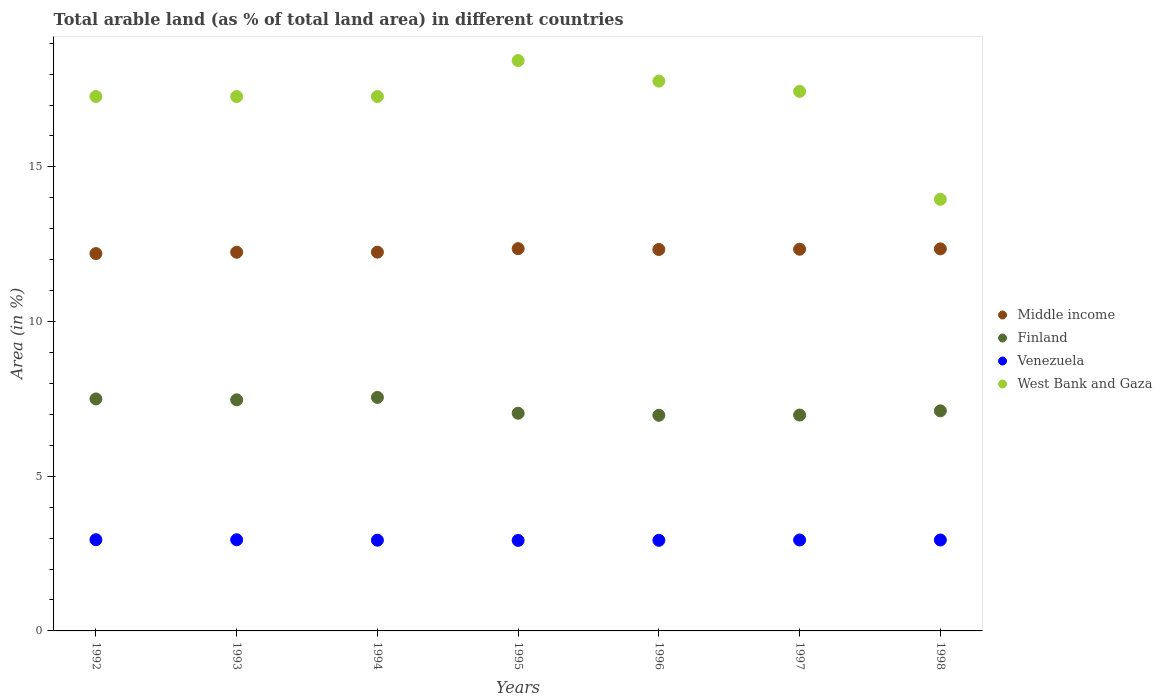How many different coloured dotlines are there?
Your response must be concise. 4. What is the percentage of arable land in Middle income in 1995?
Provide a succinct answer. 12.36. Across all years, what is the maximum percentage of arable land in Finland?
Your response must be concise. 7.55. Across all years, what is the minimum percentage of arable land in Middle income?
Provide a succinct answer. 12.2. What is the total percentage of arable land in West Bank and Gaza in the graph?
Offer a terse response. 119.44. What is the difference between the percentage of arable land in Middle income in 1995 and that in 1997?
Your response must be concise. 0.02. What is the difference between the percentage of arable land in Finland in 1993 and the percentage of arable land in Venezuela in 1994?
Ensure brevity in your answer.  4.54. What is the average percentage of arable land in Venezuela per year?
Your response must be concise. 2.94. In the year 1992, what is the difference between the percentage of arable land in Venezuela and percentage of arable land in Middle income?
Make the answer very short. -9.25. In how many years, is the percentage of arable land in Finland greater than 10 %?
Offer a very short reply. 0. What is the ratio of the percentage of arable land in Finland in 1994 to that in 1996?
Keep it short and to the point. 1.08. Is the difference between the percentage of arable land in Venezuela in 1994 and 1995 greater than the difference between the percentage of arable land in Middle income in 1994 and 1995?
Give a very brief answer. Yes. What is the difference between the highest and the second highest percentage of arable land in Venezuela?
Your response must be concise. 0. What is the difference between the highest and the lowest percentage of arable land in Venezuela?
Keep it short and to the point. 0.02. In how many years, is the percentage of arable land in Finland greater than the average percentage of arable land in Finland taken over all years?
Provide a short and direct response. 3. Is the percentage of arable land in Venezuela strictly greater than the percentage of arable land in West Bank and Gaza over the years?
Provide a short and direct response. No. Is the percentage of arable land in Middle income strictly less than the percentage of arable land in Venezuela over the years?
Offer a very short reply. No. How many dotlines are there?
Make the answer very short. 4. How many years are there in the graph?
Make the answer very short. 7. What is the difference between two consecutive major ticks on the Y-axis?
Make the answer very short. 5. Does the graph contain any zero values?
Give a very brief answer. No. How many legend labels are there?
Your answer should be very brief. 4. How are the legend labels stacked?
Provide a succinct answer. Vertical. What is the title of the graph?
Make the answer very short. Total arable land (as % of total land area) in different countries. What is the label or title of the X-axis?
Offer a terse response. Years. What is the label or title of the Y-axis?
Keep it short and to the point. Area (in %). What is the Area (in %) of Middle income in 1992?
Your answer should be compact. 12.2. What is the Area (in %) of Finland in 1992?
Give a very brief answer. 7.5. What is the Area (in %) in Venezuela in 1992?
Provide a succinct answer. 2.95. What is the Area (in %) of West Bank and Gaza in 1992?
Your answer should be compact. 17.28. What is the Area (in %) in Middle income in 1993?
Provide a succinct answer. 12.24. What is the Area (in %) in Finland in 1993?
Keep it short and to the point. 7.47. What is the Area (in %) of Venezuela in 1993?
Offer a very short reply. 2.95. What is the Area (in %) of West Bank and Gaza in 1993?
Your response must be concise. 17.28. What is the Area (in %) of Middle income in 1994?
Your response must be concise. 12.24. What is the Area (in %) of Finland in 1994?
Offer a very short reply. 7.55. What is the Area (in %) of Venezuela in 1994?
Offer a terse response. 2.93. What is the Area (in %) of West Bank and Gaza in 1994?
Your answer should be compact. 17.28. What is the Area (in %) in Middle income in 1995?
Keep it short and to the point. 12.36. What is the Area (in %) in Finland in 1995?
Provide a short and direct response. 7.04. What is the Area (in %) of Venezuela in 1995?
Offer a terse response. 2.93. What is the Area (in %) of West Bank and Gaza in 1995?
Your answer should be compact. 18.44. What is the Area (in %) of Middle income in 1996?
Give a very brief answer. 12.33. What is the Area (in %) of Finland in 1996?
Make the answer very short. 6.97. What is the Area (in %) in Venezuela in 1996?
Your answer should be very brief. 2.93. What is the Area (in %) in West Bank and Gaza in 1996?
Your response must be concise. 17.77. What is the Area (in %) in Middle income in 1997?
Your answer should be very brief. 12.34. What is the Area (in %) of Finland in 1997?
Provide a short and direct response. 6.98. What is the Area (in %) of Venezuela in 1997?
Provide a succinct answer. 2.94. What is the Area (in %) of West Bank and Gaza in 1997?
Your answer should be compact. 17.44. What is the Area (in %) in Middle income in 1998?
Offer a terse response. 12.35. What is the Area (in %) in Finland in 1998?
Offer a terse response. 7.12. What is the Area (in %) of Venezuela in 1998?
Your answer should be very brief. 2.94. What is the Area (in %) of West Bank and Gaza in 1998?
Ensure brevity in your answer.  13.95. Across all years, what is the maximum Area (in %) in Middle income?
Provide a short and direct response. 12.36. Across all years, what is the maximum Area (in %) in Finland?
Your answer should be compact. 7.55. Across all years, what is the maximum Area (in %) of Venezuela?
Provide a short and direct response. 2.95. Across all years, what is the maximum Area (in %) in West Bank and Gaza?
Offer a terse response. 18.44. Across all years, what is the minimum Area (in %) of Middle income?
Offer a very short reply. 12.2. Across all years, what is the minimum Area (in %) of Finland?
Provide a succinct answer. 6.97. Across all years, what is the minimum Area (in %) in Venezuela?
Your answer should be compact. 2.93. Across all years, what is the minimum Area (in %) of West Bank and Gaza?
Your response must be concise. 13.95. What is the total Area (in %) in Middle income in the graph?
Offer a very short reply. 86.07. What is the total Area (in %) in Finland in the graph?
Provide a short and direct response. 50.62. What is the total Area (in %) of Venezuela in the graph?
Your response must be concise. 20.56. What is the total Area (in %) in West Bank and Gaza in the graph?
Keep it short and to the point. 119.44. What is the difference between the Area (in %) of Middle income in 1992 and that in 1993?
Make the answer very short. -0.04. What is the difference between the Area (in %) in Finland in 1992 and that in 1993?
Keep it short and to the point. 0.03. What is the difference between the Area (in %) of Venezuela in 1992 and that in 1993?
Make the answer very short. 0. What is the difference between the Area (in %) of Middle income in 1992 and that in 1994?
Provide a short and direct response. -0.05. What is the difference between the Area (in %) in Finland in 1992 and that in 1994?
Ensure brevity in your answer.  -0.05. What is the difference between the Area (in %) in Venezuela in 1992 and that in 1994?
Your answer should be very brief. 0.02. What is the difference between the Area (in %) of West Bank and Gaza in 1992 and that in 1994?
Give a very brief answer. 0. What is the difference between the Area (in %) of Middle income in 1992 and that in 1995?
Offer a terse response. -0.16. What is the difference between the Area (in %) in Finland in 1992 and that in 1995?
Your answer should be very brief. 0.46. What is the difference between the Area (in %) in Venezuela in 1992 and that in 1995?
Make the answer very short. 0.02. What is the difference between the Area (in %) of West Bank and Gaza in 1992 and that in 1995?
Ensure brevity in your answer.  -1.16. What is the difference between the Area (in %) in Middle income in 1992 and that in 1996?
Ensure brevity in your answer.  -0.13. What is the difference between the Area (in %) of Finland in 1992 and that in 1996?
Provide a succinct answer. 0.53. What is the difference between the Area (in %) of Venezuela in 1992 and that in 1996?
Offer a very short reply. 0.02. What is the difference between the Area (in %) of West Bank and Gaza in 1992 and that in 1996?
Keep it short and to the point. -0.5. What is the difference between the Area (in %) in Middle income in 1992 and that in 1997?
Your answer should be compact. -0.14. What is the difference between the Area (in %) in Finland in 1992 and that in 1997?
Your answer should be compact. 0.52. What is the difference between the Area (in %) in Venezuela in 1992 and that in 1997?
Provide a short and direct response. 0.01. What is the difference between the Area (in %) of West Bank and Gaza in 1992 and that in 1997?
Make the answer very short. -0.17. What is the difference between the Area (in %) in Middle income in 1992 and that in 1998?
Ensure brevity in your answer.  -0.15. What is the difference between the Area (in %) in Finland in 1992 and that in 1998?
Offer a terse response. 0.38. What is the difference between the Area (in %) of Venezuela in 1992 and that in 1998?
Offer a terse response. 0.01. What is the difference between the Area (in %) of West Bank and Gaza in 1992 and that in 1998?
Offer a terse response. 3.32. What is the difference between the Area (in %) in Middle income in 1993 and that in 1994?
Your response must be concise. -0. What is the difference between the Area (in %) of Finland in 1993 and that in 1994?
Offer a very short reply. -0.08. What is the difference between the Area (in %) of Venezuela in 1993 and that in 1994?
Make the answer very short. 0.01. What is the difference between the Area (in %) in West Bank and Gaza in 1993 and that in 1994?
Make the answer very short. 0. What is the difference between the Area (in %) of Middle income in 1993 and that in 1995?
Your answer should be compact. -0.12. What is the difference between the Area (in %) of Finland in 1993 and that in 1995?
Make the answer very short. 0.43. What is the difference between the Area (in %) of Venezuela in 1993 and that in 1995?
Your response must be concise. 0.02. What is the difference between the Area (in %) in West Bank and Gaza in 1993 and that in 1995?
Ensure brevity in your answer.  -1.16. What is the difference between the Area (in %) in Middle income in 1993 and that in 1996?
Offer a very short reply. -0.09. What is the difference between the Area (in %) of Finland in 1993 and that in 1996?
Your response must be concise. 0.5. What is the difference between the Area (in %) in Venezuela in 1993 and that in 1996?
Make the answer very short. 0.02. What is the difference between the Area (in %) in West Bank and Gaza in 1993 and that in 1996?
Your answer should be compact. -0.5. What is the difference between the Area (in %) of Middle income in 1993 and that in 1997?
Your response must be concise. -0.1. What is the difference between the Area (in %) in Finland in 1993 and that in 1997?
Ensure brevity in your answer.  0.49. What is the difference between the Area (in %) of Venezuela in 1993 and that in 1997?
Provide a succinct answer. 0.01. What is the difference between the Area (in %) in West Bank and Gaza in 1993 and that in 1997?
Offer a terse response. -0.17. What is the difference between the Area (in %) in Middle income in 1993 and that in 1998?
Offer a terse response. -0.11. What is the difference between the Area (in %) of Finland in 1993 and that in 1998?
Provide a succinct answer. 0.36. What is the difference between the Area (in %) in Venezuela in 1993 and that in 1998?
Your response must be concise. 0.01. What is the difference between the Area (in %) of West Bank and Gaza in 1993 and that in 1998?
Give a very brief answer. 3.32. What is the difference between the Area (in %) in Middle income in 1994 and that in 1995?
Provide a short and direct response. -0.11. What is the difference between the Area (in %) of Finland in 1994 and that in 1995?
Keep it short and to the point. 0.51. What is the difference between the Area (in %) in Venezuela in 1994 and that in 1995?
Make the answer very short. 0.01. What is the difference between the Area (in %) in West Bank and Gaza in 1994 and that in 1995?
Your answer should be very brief. -1.16. What is the difference between the Area (in %) in Middle income in 1994 and that in 1996?
Your answer should be compact. -0.09. What is the difference between the Area (in %) of Finland in 1994 and that in 1996?
Your response must be concise. 0.58. What is the difference between the Area (in %) of Venezuela in 1994 and that in 1996?
Keep it short and to the point. 0. What is the difference between the Area (in %) in West Bank and Gaza in 1994 and that in 1996?
Keep it short and to the point. -0.5. What is the difference between the Area (in %) in Middle income in 1994 and that in 1997?
Your response must be concise. -0.09. What is the difference between the Area (in %) of Finland in 1994 and that in 1997?
Give a very brief answer. 0.57. What is the difference between the Area (in %) in Venezuela in 1994 and that in 1997?
Provide a succinct answer. -0.01. What is the difference between the Area (in %) of West Bank and Gaza in 1994 and that in 1997?
Provide a short and direct response. -0.17. What is the difference between the Area (in %) of Middle income in 1994 and that in 1998?
Your response must be concise. -0.11. What is the difference between the Area (in %) in Finland in 1994 and that in 1998?
Offer a very short reply. 0.43. What is the difference between the Area (in %) of Venezuela in 1994 and that in 1998?
Offer a very short reply. -0.01. What is the difference between the Area (in %) in West Bank and Gaza in 1994 and that in 1998?
Your answer should be compact. 3.32. What is the difference between the Area (in %) of Middle income in 1995 and that in 1996?
Provide a succinct answer. 0.03. What is the difference between the Area (in %) of Finland in 1995 and that in 1996?
Your answer should be compact. 0.07. What is the difference between the Area (in %) in Venezuela in 1995 and that in 1996?
Make the answer very short. -0. What is the difference between the Area (in %) of West Bank and Gaza in 1995 and that in 1996?
Offer a very short reply. 0.66. What is the difference between the Area (in %) in Middle income in 1995 and that in 1997?
Offer a terse response. 0.02. What is the difference between the Area (in %) of Finland in 1995 and that in 1997?
Your answer should be very brief. 0.06. What is the difference between the Area (in %) of Venezuela in 1995 and that in 1997?
Your answer should be compact. -0.01. What is the difference between the Area (in %) in West Bank and Gaza in 1995 and that in 1997?
Keep it short and to the point. 1. What is the difference between the Area (in %) in Middle income in 1995 and that in 1998?
Your answer should be compact. 0.01. What is the difference between the Area (in %) in Finland in 1995 and that in 1998?
Provide a succinct answer. -0.08. What is the difference between the Area (in %) in Venezuela in 1995 and that in 1998?
Provide a short and direct response. -0.01. What is the difference between the Area (in %) in West Bank and Gaza in 1995 and that in 1998?
Your answer should be compact. 4.49. What is the difference between the Area (in %) of Middle income in 1996 and that in 1997?
Offer a terse response. -0.01. What is the difference between the Area (in %) in Finland in 1996 and that in 1997?
Provide a short and direct response. -0.01. What is the difference between the Area (in %) in Venezuela in 1996 and that in 1997?
Your answer should be very brief. -0.01. What is the difference between the Area (in %) of West Bank and Gaza in 1996 and that in 1997?
Your response must be concise. 0.33. What is the difference between the Area (in %) in Middle income in 1996 and that in 1998?
Ensure brevity in your answer.  -0.02. What is the difference between the Area (in %) in Finland in 1996 and that in 1998?
Give a very brief answer. -0.14. What is the difference between the Area (in %) of Venezuela in 1996 and that in 1998?
Ensure brevity in your answer.  -0.01. What is the difference between the Area (in %) of West Bank and Gaza in 1996 and that in 1998?
Provide a short and direct response. 3.82. What is the difference between the Area (in %) in Middle income in 1997 and that in 1998?
Make the answer very short. -0.01. What is the difference between the Area (in %) of Finland in 1997 and that in 1998?
Make the answer very short. -0.14. What is the difference between the Area (in %) in West Bank and Gaza in 1997 and that in 1998?
Make the answer very short. 3.49. What is the difference between the Area (in %) of Middle income in 1992 and the Area (in %) of Finland in 1993?
Provide a short and direct response. 4.73. What is the difference between the Area (in %) of Middle income in 1992 and the Area (in %) of Venezuela in 1993?
Your answer should be very brief. 9.25. What is the difference between the Area (in %) in Middle income in 1992 and the Area (in %) in West Bank and Gaza in 1993?
Keep it short and to the point. -5.08. What is the difference between the Area (in %) in Finland in 1992 and the Area (in %) in Venezuela in 1993?
Provide a succinct answer. 4.55. What is the difference between the Area (in %) in Finland in 1992 and the Area (in %) in West Bank and Gaza in 1993?
Provide a short and direct response. -9.78. What is the difference between the Area (in %) of Venezuela in 1992 and the Area (in %) of West Bank and Gaza in 1993?
Keep it short and to the point. -14.33. What is the difference between the Area (in %) of Middle income in 1992 and the Area (in %) of Finland in 1994?
Provide a short and direct response. 4.65. What is the difference between the Area (in %) in Middle income in 1992 and the Area (in %) in Venezuela in 1994?
Make the answer very short. 9.27. What is the difference between the Area (in %) in Middle income in 1992 and the Area (in %) in West Bank and Gaza in 1994?
Your answer should be very brief. -5.08. What is the difference between the Area (in %) in Finland in 1992 and the Area (in %) in Venezuela in 1994?
Make the answer very short. 4.57. What is the difference between the Area (in %) of Finland in 1992 and the Area (in %) of West Bank and Gaza in 1994?
Keep it short and to the point. -9.78. What is the difference between the Area (in %) of Venezuela in 1992 and the Area (in %) of West Bank and Gaza in 1994?
Provide a short and direct response. -14.33. What is the difference between the Area (in %) in Middle income in 1992 and the Area (in %) in Finland in 1995?
Keep it short and to the point. 5.16. What is the difference between the Area (in %) of Middle income in 1992 and the Area (in %) of Venezuela in 1995?
Give a very brief answer. 9.27. What is the difference between the Area (in %) in Middle income in 1992 and the Area (in %) in West Bank and Gaza in 1995?
Provide a succinct answer. -6.24. What is the difference between the Area (in %) of Finland in 1992 and the Area (in %) of Venezuela in 1995?
Keep it short and to the point. 4.57. What is the difference between the Area (in %) of Finland in 1992 and the Area (in %) of West Bank and Gaza in 1995?
Your answer should be very brief. -10.94. What is the difference between the Area (in %) in Venezuela in 1992 and the Area (in %) in West Bank and Gaza in 1995?
Provide a short and direct response. -15.49. What is the difference between the Area (in %) in Middle income in 1992 and the Area (in %) in Finland in 1996?
Your response must be concise. 5.23. What is the difference between the Area (in %) of Middle income in 1992 and the Area (in %) of Venezuela in 1996?
Your answer should be very brief. 9.27. What is the difference between the Area (in %) of Middle income in 1992 and the Area (in %) of West Bank and Gaza in 1996?
Your response must be concise. -5.58. What is the difference between the Area (in %) of Finland in 1992 and the Area (in %) of Venezuela in 1996?
Offer a terse response. 4.57. What is the difference between the Area (in %) in Finland in 1992 and the Area (in %) in West Bank and Gaza in 1996?
Keep it short and to the point. -10.27. What is the difference between the Area (in %) in Venezuela in 1992 and the Area (in %) in West Bank and Gaza in 1996?
Make the answer very short. -14.83. What is the difference between the Area (in %) in Middle income in 1992 and the Area (in %) in Finland in 1997?
Provide a succinct answer. 5.22. What is the difference between the Area (in %) of Middle income in 1992 and the Area (in %) of Venezuela in 1997?
Offer a terse response. 9.26. What is the difference between the Area (in %) in Middle income in 1992 and the Area (in %) in West Bank and Gaza in 1997?
Your answer should be very brief. -5.24. What is the difference between the Area (in %) of Finland in 1992 and the Area (in %) of Venezuela in 1997?
Your answer should be compact. 4.56. What is the difference between the Area (in %) in Finland in 1992 and the Area (in %) in West Bank and Gaza in 1997?
Your response must be concise. -9.94. What is the difference between the Area (in %) in Venezuela in 1992 and the Area (in %) in West Bank and Gaza in 1997?
Offer a very short reply. -14.49. What is the difference between the Area (in %) of Middle income in 1992 and the Area (in %) of Finland in 1998?
Give a very brief answer. 5.08. What is the difference between the Area (in %) in Middle income in 1992 and the Area (in %) in Venezuela in 1998?
Your response must be concise. 9.26. What is the difference between the Area (in %) of Middle income in 1992 and the Area (in %) of West Bank and Gaza in 1998?
Offer a very short reply. -1.75. What is the difference between the Area (in %) in Finland in 1992 and the Area (in %) in Venezuela in 1998?
Ensure brevity in your answer.  4.56. What is the difference between the Area (in %) of Finland in 1992 and the Area (in %) of West Bank and Gaza in 1998?
Your response must be concise. -6.45. What is the difference between the Area (in %) of Venezuela in 1992 and the Area (in %) of West Bank and Gaza in 1998?
Make the answer very short. -11. What is the difference between the Area (in %) in Middle income in 1993 and the Area (in %) in Finland in 1994?
Make the answer very short. 4.69. What is the difference between the Area (in %) in Middle income in 1993 and the Area (in %) in Venezuela in 1994?
Your response must be concise. 9.31. What is the difference between the Area (in %) of Middle income in 1993 and the Area (in %) of West Bank and Gaza in 1994?
Make the answer very short. -5.03. What is the difference between the Area (in %) of Finland in 1993 and the Area (in %) of Venezuela in 1994?
Ensure brevity in your answer.  4.54. What is the difference between the Area (in %) of Finland in 1993 and the Area (in %) of West Bank and Gaza in 1994?
Provide a succinct answer. -9.8. What is the difference between the Area (in %) of Venezuela in 1993 and the Area (in %) of West Bank and Gaza in 1994?
Give a very brief answer. -14.33. What is the difference between the Area (in %) in Middle income in 1993 and the Area (in %) in Finland in 1995?
Offer a very short reply. 5.2. What is the difference between the Area (in %) of Middle income in 1993 and the Area (in %) of Venezuela in 1995?
Provide a succinct answer. 9.32. What is the difference between the Area (in %) of Middle income in 1993 and the Area (in %) of West Bank and Gaza in 1995?
Ensure brevity in your answer.  -6.2. What is the difference between the Area (in %) of Finland in 1993 and the Area (in %) of Venezuela in 1995?
Ensure brevity in your answer.  4.54. What is the difference between the Area (in %) of Finland in 1993 and the Area (in %) of West Bank and Gaza in 1995?
Your response must be concise. -10.97. What is the difference between the Area (in %) in Venezuela in 1993 and the Area (in %) in West Bank and Gaza in 1995?
Provide a short and direct response. -15.49. What is the difference between the Area (in %) in Middle income in 1993 and the Area (in %) in Finland in 1996?
Offer a terse response. 5.27. What is the difference between the Area (in %) in Middle income in 1993 and the Area (in %) in Venezuela in 1996?
Provide a succinct answer. 9.31. What is the difference between the Area (in %) in Middle income in 1993 and the Area (in %) in West Bank and Gaza in 1996?
Your answer should be compact. -5.53. What is the difference between the Area (in %) in Finland in 1993 and the Area (in %) in Venezuela in 1996?
Provide a succinct answer. 4.54. What is the difference between the Area (in %) in Finland in 1993 and the Area (in %) in West Bank and Gaza in 1996?
Provide a short and direct response. -10.3. What is the difference between the Area (in %) of Venezuela in 1993 and the Area (in %) of West Bank and Gaza in 1996?
Offer a terse response. -14.83. What is the difference between the Area (in %) of Middle income in 1993 and the Area (in %) of Finland in 1997?
Offer a terse response. 5.26. What is the difference between the Area (in %) in Middle income in 1993 and the Area (in %) in Venezuela in 1997?
Your answer should be very brief. 9.3. What is the difference between the Area (in %) of Middle income in 1993 and the Area (in %) of West Bank and Gaza in 1997?
Your answer should be compact. -5.2. What is the difference between the Area (in %) in Finland in 1993 and the Area (in %) in Venezuela in 1997?
Provide a short and direct response. 4.53. What is the difference between the Area (in %) of Finland in 1993 and the Area (in %) of West Bank and Gaza in 1997?
Make the answer very short. -9.97. What is the difference between the Area (in %) in Venezuela in 1993 and the Area (in %) in West Bank and Gaza in 1997?
Make the answer very short. -14.5. What is the difference between the Area (in %) of Middle income in 1993 and the Area (in %) of Finland in 1998?
Your answer should be very brief. 5.13. What is the difference between the Area (in %) of Middle income in 1993 and the Area (in %) of Venezuela in 1998?
Give a very brief answer. 9.3. What is the difference between the Area (in %) in Middle income in 1993 and the Area (in %) in West Bank and Gaza in 1998?
Give a very brief answer. -1.71. What is the difference between the Area (in %) of Finland in 1993 and the Area (in %) of Venezuela in 1998?
Your response must be concise. 4.53. What is the difference between the Area (in %) in Finland in 1993 and the Area (in %) in West Bank and Gaza in 1998?
Make the answer very short. -6.48. What is the difference between the Area (in %) in Venezuela in 1993 and the Area (in %) in West Bank and Gaza in 1998?
Your answer should be compact. -11.01. What is the difference between the Area (in %) of Middle income in 1994 and the Area (in %) of Finland in 1995?
Your answer should be very brief. 5.21. What is the difference between the Area (in %) of Middle income in 1994 and the Area (in %) of Venezuela in 1995?
Provide a succinct answer. 9.32. What is the difference between the Area (in %) in Middle income in 1994 and the Area (in %) in West Bank and Gaza in 1995?
Offer a terse response. -6.19. What is the difference between the Area (in %) of Finland in 1994 and the Area (in %) of Venezuela in 1995?
Keep it short and to the point. 4.62. What is the difference between the Area (in %) in Finland in 1994 and the Area (in %) in West Bank and Gaza in 1995?
Offer a very short reply. -10.89. What is the difference between the Area (in %) in Venezuela in 1994 and the Area (in %) in West Bank and Gaza in 1995?
Your answer should be very brief. -15.51. What is the difference between the Area (in %) in Middle income in 1994 and the Area (in %) in Finland in 1996?
Provide a short and direct response. 5.27. What is the difference between the Area (in %) of Middle income in 1994 and the Area (in %) of Venezuela in 1996?
Your response must be concise. 9.32. What is the difference between the Area (in %) of Middle income in 1994 and the Area (in %) of West Bank and Gaza in 1996?
Your answer should be compact. -5.53. What is the difference between the Area (in %) of Finland in 1994 and the Area (in %) of Venezuela in 1996?
Make the answer very short. 4.62. What is the difference between the Area (in %) in Finland in 1994 and the Area (in %) in West Bank and Gaza in 1996?
Your response must be concise. -10.22. What is the difference between the Area (in %) of Venezuela in 1994 and the Area (in %) of West Bank and Gaza in 1996?
Provide a short and direct response. -14.84. What is the difference between the Area (in %) of Middle income in 1994 and the Area (in %) of Finland in 1997?
Offer a terse response. 5.27. What is the difference between the Area (in %) in Middle income in 1994 and the Area (in %) in Venezuela in 1997?
Give a very brief answer. 9.31. What is the difference between the Area (in %) in Middle income in 1994 and the Area (in %) in West Bank and Gaza in 1997?
Offer a very short reply. -5.2. What is the difference between the Area (in %) of Finland in 1994 and the Area (in %) of Venezuela in 1997?
Your response must be concise. 4.61. What is the difference between the Area (in %) of Finland in 1994 and the Area (in %) of West Bank and Gaza in 1997?
Offer a very short reply. -9.89. What is the difference between the Area (in %) in Venezuela in 1994 and the Area (in %) in West Bank and Gaza in 1997?
Give a very brief answer. -14.51. What is the difference between the Area (in %) in Middle income in 1994 and the Area (in %) in Finland in 1998?
Offer a terse response. 5.13. What is the difference between the Area (in %) of Middle income in 1994 and the Area (in %) of Venezuela in 1998?
Your answer should be very brief. 9.31. What is the difference between the Area (in %) in Middle income in 1994 and the Area (in %) in West Bank and Gaza in 1998?
Keep it short and to the point. -1.71. What is the difference between the Area (in %) in Finland in 1994 and the Area (in %) in Venezuela in 1998?
Give a very brief answer. 4.61. What is the difference between the Area (in %) in Finland in 1994 and the Area (in %) in West Bank and Gaza in 1998?
Offer a terse response. -6.4. What is the difference between the Area (in %) in Venezuela in 1994 and the Area (in %) in West Bank and Gaza in 1998?
Ensure brevity in your answer.  -11.02. What is the difference between the Area (in %) of Middle income in 1995 and the Area (in %) of Finland in 1996?
Your response must be concise. 5.39. What is the difference between the Area (in %) in Middle income in 1995 and the Area (in %) in Venezuela in 1996?
Offer a very short reply. 9.43. What is the difference between the Area (in %) of Middle income in 1995 and the Area (in %) of West Bank and Gaza in 1996?
Provide a succinct answer. -5.42. What is the difference between the Area (in %) in Finland in 1995 and the Area (in %) in Venezuela in 1996?
Your answer should be very brief. 4.11. What is the difference between the Area (in %) in Finland in 1995 and the Area (in %) in West Bank and Gaza in 1996?
Your response must be concise. -10.74. What is the difference between the Area (in %) in Venezuela in 1995 and the Area (in %) in West Bank and Gaza in 1996?
Ensure brevity in your answer.  -14.85. What is the difference between the Area (in %) in Middle income in 1995 and the Area (in %) in Finland in 1997?
Provide a short and direct response. 5.38. What is the difference between the Area (in %) in Middle income in 1995 and the Area (in %) in Venezuela in 1997?
Your answer should be compact. 9.42. What is the difference between the Area (in %) in Middle income in 1995 and the Area (in %) in West Bank and Gaza in 1997?
Keep it short and to the point. -5.08. What is the difference between the Area (in %) in Finland in 1995 and the Area (in %) in Venezuela in 1997?
Your answer should be compact. 4.1. What is the difference between the Area (in %) in Finland in 1995 and the Area (in %) in West Bank and Gaza in 1997?
Your answer should be very brief. -10.4. What is the difference between the Area (in %) in Venezuela in 1995 and the Area (in %) in West Bank and Gaza in 1997?
Offer a terse response. -14.52. What is the difference between the Area (in %) of Middle income in 1995 and the Area (in %) of Finland in 1998?
Provide a short and direct response. 5.24. What is the difference between the Area (in %) of Middle income in 1995 and the Area (in %) of Venezuela in 1998?
Your answer should be very brief. 9.42. What is the difference between the Area (in %) of Middle income in 1995 and the Area (in %) of West Bank and Gaza in 1998?
Offer a terse response. -1.59. What is the difference between the Area (in %) in Finland in 1995 and the Area (in %) in Venezuela in 1998?
Make the answer very short. 4.1. What is the difference between the Area (in %) in Finland in 1995 and the Area (in %) in West Bank and Gaza in 1998?
Ensure brevity in your answer.  -6.92. What is the difference between the Area (in %) of Venezuela in 1995 and the Area (in %) of West Bank and Gaza in 1998?
Offer a very short reply. -11.03. What is the difference between the Area (in %) of Middle income in 1996 and the Area (in %) of Finland in 1997?
Your answer should be very brief. 5.35. What is the difference between the Area (in %) in Middle income in 1996 and the Area (in %) in Venezuela in 1997?
Offer a terse response. 9.39. What is the difference between the Area (in %) of Middle income in 1996 and the Area (in %) of West Bank and Gaza in 1997?
Your response must be concise. -5.11. What is the difference between the Area (in %) in Finland in 1996 and the Area (in %) in Venezuela in 1997?
Your response must be concise. 4.03. What is the difference between the Area (in %) of Finland in 1996 and the Area (in %) of West Bank and Gaza in 1997?
Keep it short and to the point. -10.47. What is the difference between the Area (in %) of Venezuela in 1996 and the Area (in %) of West Bank and Gaza in 1997?
Give a very brief answer. -14.51. What is the difference between the Area (in %) in Middle income in 1996 and the Area (in %) in Finland in 1998?
Your answer should be very brief. 5.22. What is the difference between the Area (in %) in Middle income in 1996 and the Area (in %) in Venezuela in 1998?
Keep it short and to the point. 9.39. What is the difference between the Area (in %) of Middle income in 1996 and the Area (in %) of West Bank and Gaza in 1998?
Ensure brevity in your answer.  -1.62. What is the difference between the Area (in %) of Finland in 1996 and the Area (in %) of Venezuela in 1998?
Give a very brief answer. 4.03. What is the difference between the Area (in %) of Finland in 1996 and the Area (in %) of West Bank and Gaza in 1998?
Your answer should be compact. -6.98. What is the difference between the Area (in %) in Venezuela in 1996 and the Area (in %) in West Bank and Gaza in 1998?
Offer a terse response. -11.02. What is the difference between the Area (in %) of Middle income in 1997 and the Area (in %) of Finland in 1998?
Ensure brevity in your answer.  5.22. What is the difference between the Area (in %) of Middle income in 1997 and the Area (in %) of Venezuela in 1998?
Offer a very short reply. 9.4. What is the difference between the Area (in %) of Middle income in 1997 and the Area (in %) of West Bank and Gaza in 1998?
Your answer should be compact. -1.61. What is the difference between the Area (in %) in Finland in 1997 and the Area (in %) in Venezuela in 1998?
Keep it short and to the point. 4.04. What is the difference between the Area (in %) in Finland in 1997 and the Area (in %) in West Bank and Gaza in 1998?
Make the answer very short. -6.97. What is the difference between the Area (in %) in Venezuela in 1997 and the Area (in %) in West Bank and Gaza in 1998?
Offer a very short reply. -11.01. What is the average Area (in %) in Middle income per year?
Provide a short and direct response. 12.3. What is the average Area (in %) of Finland per year?
Offer a very short reply. 7.23. What is the average Area (in %) of Venezuela per year?
Your response must be concise. 2.94. What is the average Area (in %) in West Bank and Gaza per year?
Provide a short and direct response. 17.06. In the year 1992, what is the difference between the Area (in %) in Middle income and Area (in %) in Finland?
Keep it short and to the point. 4.7. In the year 1992, what is the difference between the Area (in %) of Middle income and Area (in %) of Venezuela?
Give a very brief answer. 9.25. In the year 1992, what is the difference between the Area (in %) of Middle income and Area (in %) of West Bank and Gaza?
Keep it short and to the point. -5.08. In the year 1992, what is the difference between the Area (in %) in Finland and Area (in %) in Venezuela?
Your response must be concise. 4.55. In the year 1992, what is the difference between the Area (in %) in Finland and Area (in %) in West Bank and Gaza?
Provide a short and direct response. -9.78. In the year 1992, what is the difference between the Area (in %) in Venezuela and Area (in %) in West Bank and Gaza?
Your answer should be very brief. -14.33. In the year 1993, what is the difference between the Area (in %) in Middle income and Area (in %) in Finland?
Provide a succinct answer. 4.77. In the year 1993, what is the difference between the Area (in %) of Middle income and Area (in %) of Venezuela?
Your answer should be very brief. 9.3. In the year 1993, what is the difference between the Area (in %) in Middle income and Area (in %) in West Bank and Gaza?
Offer a terse response. -5.03. In the year 1993, what is the difference between the Area (in %) of Finland and Area (in %) of Venezuela?
Offer a terse response. 4.52. In the year 1993, what is the difference between the Area (in %) of Finland and Area (in %) of West Bank and Gaza?
Offer a terse response. -9.8. In the year 1993, what is the difference between the Area (in %) of Venezuela and Area (in %) of West Bank and Gaza?
Make the answer very short. -14.33. In the year 1994, what is the difference between the Area (in %) of Middle income and Area (in %) of Finland?
Provide a succinct answer. 4.69. In the year 1994, what is the difference between the Area (in %) in Middle income and Area (in %) in Venezuela?
Make the answer very short. 9.31. In the year 1994, what is the difference between the Area (in %) of Middle income and Area (in %) of West Bank and Gaza?
Your answer should be compact. -5.03. In the year 1994, what is the difference between the Area (in %) in Finland and Area (in %) in Venezuela?
Offer a very short reply. 4.62. In the year 1994, what is the difference between the Area (in %) in Finland and Area (in %) in West Bank and Gaza?
Give a very brief answer. -9.73. In the year 1994, what is the difference between the Area (in %) of Venezuela and Area (in %) of West Bank and Gaza?
Your answer should be compact. -14.34. In the year 1995, what is the difference between the Area (in %) of Middle income and Area (in %) of Finland?
Offer a very short reply. 5.32. In the year 1995, what is the difference between the Area (in %) of Middle income and Area (in %) of Venezuela?
Provide a short and direct response. 9.43. In the year 1995, what is the difference between the Area (in %) in Middle income and Area (in %) in West Bank and Gaza?
Give a very brief answer. -6.08. In the year 1995, what is the difference between the Area (in %) in Finland and Area (in %) in Venezuela?
Offer a very short reply. 4.11. In the year 1995, what is the difference between the Area (in %) of Finland and Area (in %) of West Bank and Gaza?
Provide a short and direct response. -11.4. In the year 1995, what is the difference between the Area (in %) in Venezuela and Area (in %) in West Bank and Gaza?
Your answer should be compact. -15.51. In the year 1996, what is the difference between the Area (in %) of Middle income and Area (in %) of Finland?
Your response must be concise. 5.36. In the year 1996, what is the difference between the Area (in %) of Middle income and Area (in %) of Venezuela?
Make the answer very short. 9.4. In the year 1996, what is the difference between the Area (in %) in Middle income and Area (in %) in West Bank and Gaza?
Give a very brief answer. -5.44. In the year 1996, what is the difference between the Area (in %) of Finland and Area (in %) of Venezuela?
Your response must be concise. 4.04. In the year 1996, what is the difference between the Area (in %) of Finland and Area (in %) of West Bank and Gaza?
Offer a terse response. -10.8. In the year 1996, what is the difference between the Area (in %) in Venezuela and Area (in %) in West Bank and Gaza?
Your answer should be compact. -14.84. In the year 1997, what is the difference between the Area (in %) of Middle income and Area (in %) of Finland?
Your response must be concise. 5.36. In the year 1997, what is the difference between the Area (in %) of Middle income and Area (in %) of West Bank and Gaza?
Keep it short and to the point. -5.1. In the year 1997, what is the difference between the Area (in %) in Finland and Area (in %) in Venezuela?
Give a very brief answer. 4.04. In the year 1997, what is the difference between the Area (in %) of Finland and Area (in %) of West Bank and Gaza?
Keep it short and to the point. -10.46. In the year 1997, what is the difference between the Area (in %) in Venezuela and Area (in %) in West Bank and Gaza?
Give a very brief answer. -14.5. In the year 1998, what is the difference between the Area (in %) of Middle income and Area (in %) of Finland?
Ensure brevity in your answer.  5.24. In the year 1998, what is the difference between the Area (in %) of Middle income and Area (in %) of Venezuela?
Offer a very short reply. 9.41. In the year 1998, what is the difference between the Area (in %) in Middle income and Area (in %) in West Bank and Gaza?
Make the answer very short. -1.6. In the year 1998, what is the difference between the Area (in %) of Finland and Area (in %) of Venezuela?
Keep it short and to the point. 4.18. In the year 1998, what is the difference between the Area (in %) in Finland and Area (in %) in West Bank and Gaza?
Provide a short and direct response. -6.84. In the year 1998, what is the difference between the Area (in %) of Venezuela and Area (in %) of West Bank and Gaza?
Offer a very short reply. -11.01. What is the ratio of the Area (in %) of Finland in 1992 to that in 1993?
Offer a very short reply. 1. What is the ratio of the Area (in %) of Middle income in 1992 to that in 1994?
Give a very brief answer. 1. What is the ratio of the Area (in %) in Finland in 1992 to that in 1994?
Your answer should be compact. 0.99. What is the ratio of the Area (in %) of Venezuela in 1992 to that in 1994?
Your answer should be very brief. 1.01. What is the ratio of the Area (in %) of West Bank and Gaza in 1992 to that in 1994?
Your answer should be compact. 1. What is the ratio of the Area (in %) in Middle income in 1992 to that in 1995?
Your answer should be compact. 0.99. What is the ratio of the Area (in %) in Finland in 1992 to that in 1995?
Your answer should be compact. 1.07. What is the ratio of the Area (in %) of Venezuela in 1992 to that in 1995?
Your answer should be compact. 1.01. What is the ratio of the Area (in %) in West Bank and Gaza in 1992 to that in 1995?
Keep it short and to the point. 0.94. What is the ratio of the Area (in %) in Middle income in 1992 to that in 1996?
Your response must be concise. 0.99. What is the ratio of the Area (in %) in Finland in 1992 to that in 1996?
Keep it short and to the point. 1.08. What is the ratio of the Area (in %) in Venezuela in 1992 to that in 1996?
Provide a short and direct response. 1.01. What is the ratio of the Area (in %) in West Bank and Gaza in 1992 to that in 1996?
Your answer should be compact. 0.97. What is the ratio of the Area (in %) of Middle income in 1992 to that in 1997?
Ensure brevity in your answer.  0.99. What is the ratio of the Area (in %) in Finland in 1992 to that in 1997?
Make the answer very short. 1.07. What is the ratio of the Area (in %) in Venezuela in 1992 to that in 1997?
Provide a succinct answer. 1. What is the ratio of the Area (in %) in Finland in 1992 to that in 1998?
Your response must be concise. 1.05. What is the ratio of the Area (in %) in West Bank and Gaza in 1992 to that in 1998?
Provide a short and direct response. 1.24. What is the ratio of the Area (in %) in Middle income in 1993 to that in 1994?
Your answer should be compact. 1. What is the ratio of the Area (in %) of Finland in 1993 to that in 1994?
Make the answer very short. 0.99. What is the ratio of the Area (in %) in Venezuela in 1993 to that in 1994?
Provide a short and direct response. 1. What is the ratio of the Area (in %) in West Bank and Gaza in 1993 to that in 1994?
Provide a short and direct response. 1. What is the ratio of the Area (in %) in Middle income in 1993 to that in 1995?
Ensure brevity in your answer.  0.99. What is the ratio of the Area (in %) in Finland in 1993 to that in 1995?
Offer a terse response. 1.06. What is the ratio of the Area (in %) of West Bank and Gaza in 1993 to that in 1995?
Offer a terse response. 0.94. What is the ratio of the Area (in %) of Middle income in 1993 to that in 1996?
Your response must be concise. 0.99. What is the ratio of the Area (in %) of Finland in 1993 to that in 1996?
Give a very brief answer. 1.07. What is the ratio of the Area (in %) in West Bank and Gaza in 1993 to that in 1996?
Make the answer very short. 0.97. What is the ratio of the Area (in %) of Middle income in 1993 to that in 1997?
Keep it short and to the point. 0.99. What is the ratio of the Area (in %) of Finland in 1993 to that in 1997?
Your answer should be compact. 1.07. What is the ratio of the Area (in %) of Finland in 1993 to that in 1998?
Keep it short and to the point. 1.05. What is the ratio of the Area (in %) of Venezuela in 1993 to that in 1998?
Provide a short and direct response. 1. What is the ratio of the Area (in %) in West Bank and Gaza in 1993 to that in 1998?
Provide a succinct answer. 1.24. What is the ratio of the Area (in %) of Middle income in 1994 to that in 1995?
Provide a short and direct response. 0.99. What is the ratio of the Area (in %) in Finland in 1994 to that in 1995?
Your answer should be compact. 1.07. What is the ratio of the Area (in %) in Venezuela in 1994 to that in 1995?
Offer a terse response. 1. What is the ratio of the Area (in %) in West Bank and Gaza in 1994 to that in 1995?
Provide a short and direct response. 0.94. What is the ratio of the Area (in %) in Middle income in 1994 to that in 1996?
Your answer should be very brief. 0.99. What is the ratio of the Area (in %) in Finland in 1994 to that in 1996?
Your answer should be very brief. 1.08. What is the ratio of the Area (in %) of Venezuela in 1994 to that in 1996?
Your response must be concise. 1. What is the ratio of the Area (in %) of West Bank and Gaza in 1994 to that in 1996?
Offer a very short reply. 0.97. What is the ratio of the Area (in %) in Finland in 1994 to that in 1997?
Your response must be concise. 1.08. What is the ratio of the Area (in %) in Venezuela in 1994 to that in 1997?
Ensure brevity in your answer.  1. What is the ratio of the Area (in %) in West Bank and Gaza in 1994 to that in 1997?
Keep it short and to the point. 0.99. What is the ratio of the Area (in %) of Finland in 1994 to that in 1998?
Ensure brevity in your answer.  1.06. What is the ratio of the Area (in %) of West Bank and Gaza in 1994 to that in 1998?
Offer a very short reply. 1.24. What is the ratio of the Area (in %) of Finland in 1995 to that in 1996?
Your answer should be compact. 1.01. What is the ratio of the Area (in %) in West Bank and Gaza in 1995 to that in 1996?
Your answer should be very brief. 1.04. What is the ratio of the Area (in %) of Finland in 1995 to that in 1997?
Provide a succinct answer. 1.01. What is the ratio of the Area (in %) in Venezuela in 1995 to that in 1997?
Provide a succinct answer. 1. What is the ratio of the Area (in %) of West Bank and Gaza in 1995 to that in 1997?
Make the answer very short. 1.06. What is the ratio of the Area (in %) of Finland in 1995 to that in 1998?
Your answer should be compact. 0.99. What is the ratio of the Area (in %) of West Bank and Gaza in 1995 to that in 1998?
Your response must be concise. 1.32. What is the ratio of the Area (in %) of Middle income in 1996 to that in 1997?
Offer a very short reply. 1. What is the ratio of the Area (in %) in Venezuela in 1996 to that in 1997?
Your answer should be very brief. 1. What is the ratio of the Area (in %) of Finland in 1996 to that in 1998?
Make the answer very short. 0.98. What is the ratio of the Area (in %) of West Bank and Gaza in 1996 to that in 1998?
Your answer should be compact. 1.27. What is the ratio of the Area (in %) in Finland in 1997 to that in 1998?
Give a very brief answer. 0.98. What is the ratio of the Area (in %) in Venezuela in 1997 to that in 1998?
Offer a terse response. 1. What is the ratio of the Area (in %) of West Bank and Gaza in 1997 to that in 1998?
Offer a terse response. 1.25. What is the difference between the highest and the second highest Area (in %) in Middle income?
Your answer should be compact. 0.01. What is the difference between the highest and the second highest Area (in %) of Finland?
Make the answer very short. 0.05. What is the difference between the highest and the second highest Area (in %) in Venezuela?
Provide a short and direct response. 0. What is the difference between the highest and the second highest Area (in %) of West Bank and Gaza?
Provide a short and direct response. 0.66. What is the difference between the highest and the lowest Area (in %) in Middle income?
Your response must be concise. 0.16. What is the difference between the highest and the lowest Area (in %) of Finland?
Keep it short and to the point. 0.58. What is the difference between the highest and the lowest Area (in %) of Venezuela?
Make the answer very short. 0.02. What is the difference between the highest and the lowest Area (in %) of West Bank and Gaza?
Make the answer very short. 4.49. 